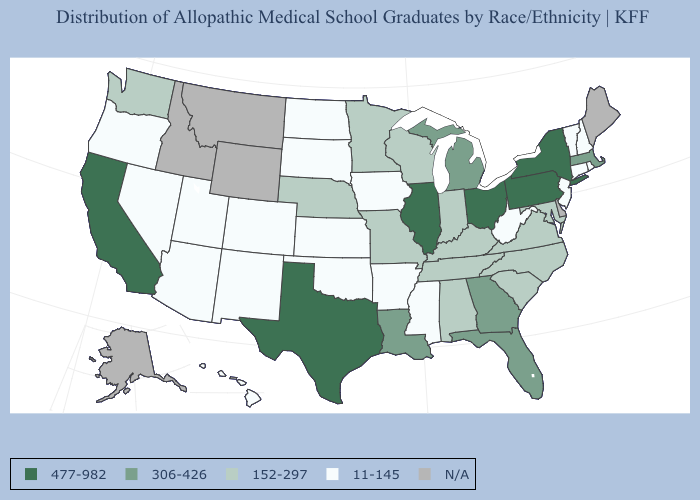Does the map have missing data?
Be succinct. Yes. Name the states that have a value in the range 11-145?
Give a very brief answer. Arizona, Arkansas, Colorado, Connecticut, Hawaii, Iowa, Kansas, Mississippi, Nevada, New Hampshire, New Jersey, New Mexico, North Dakota, Oklahoma, Oregon, Rhode Island, South Dakota, Utah, Vermont, West Virginia. What is the value of Illinois?
Quick response, please. 477-982. Does Mississippi have the lowest value in the South?
Short answer required. Yes. Name the states that have a value in the range 152-297?
Concise answer only. Alabama, Indiana, Kentucky, Maryland, Minnesota, Missouri, Nebraska, North Carolina, South Carolina, Tennessee, Virginia, Washington, Wisconsin. What is the value of Wyoming?
Concise answer only. N/A. What is the lowest value in states that border New Jersey?
Give a very brief answer. 477-982. Name the states that have a value in the range 11-145?
Be succinct. Arizona, Arkansas, Colorado, Connecticut, Hawaii, Iowa, Kansas, Mississippi, Nevada, New Hampshire, New Jersey, New Mexico, North Dakota, Oklahoma, Oregon, Rhode Island, South Dakota, Utah, Vermont, West Virginia. Name the states that have a value in the range N/A?
Short answer required. Alaska, Delaware, Idaho, Maine, Montana, Wyoming. What is the value of Nevada?
Give a very brief answer. 11-145. Name the states that have a value in the range 152-297?
Be succinct. Alabama, Indiana, Kentucky, Maryland, Minnesota, Missouri, Nebraska, North Carolina, South Carolina, Tennessee, Virginia, Washington, Wisconsin. Name the states that have a value in the range 477-982?
Be succinct. California, Illinois, New York, Ohio, Pennsylvania, Texas. What is the lowest value in the USA?
Be succinct. 11-145. 